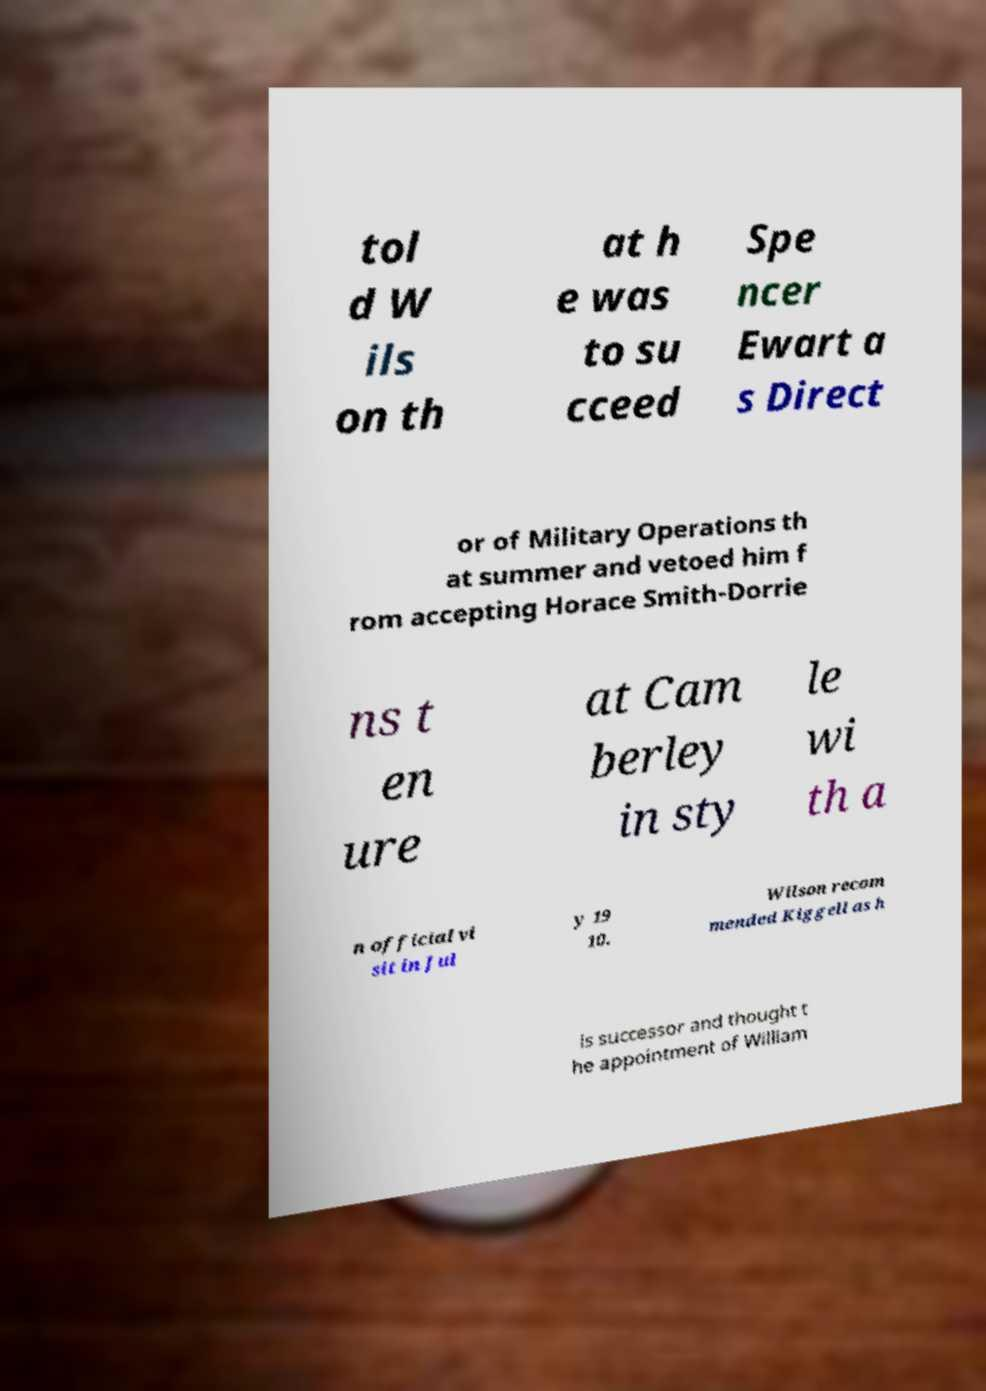Could you extract and type out the text from this image? tol d W ils on th at h e was to su cceed Spe ncer Ewart a s Direct or of Military Operations th at summer and vetoed him f rom accepting Horace Smith-Dorrie ns t en ure at Cam berley in sty le wi th a n official vi sit in Jul y 19 10. Wilson recom mended Kiggell as h is successor and thought t he appointment of William 